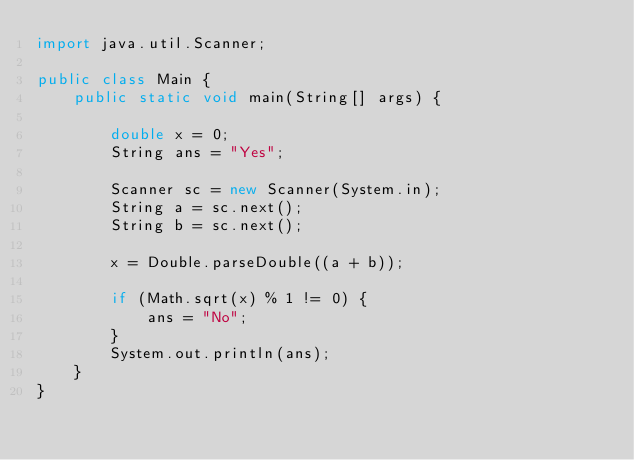<code> <loc_0><loc_0><loc_500><loc_500><_Java_>import java.util.Scanner;

public class Main {
    public static void main(String[] args) {

        double x = 0;
        String ans = "Yes";

        Scanner sc = new Scanner(System.in);
        String a = sc.next();
        String b = sc.next();

        x = Double.parseDouble((a + b));

        if (Math.sqrt(x) % 1 != 0) {
            ans = "No";
        }
        System.out.println(ans);
    }
}
</code> 